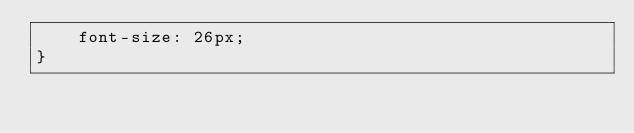Convert code to text. <code><loc_0><loc_0><loc_500><loc_500><_CSS_>    font-size: 26px;
}</code> 